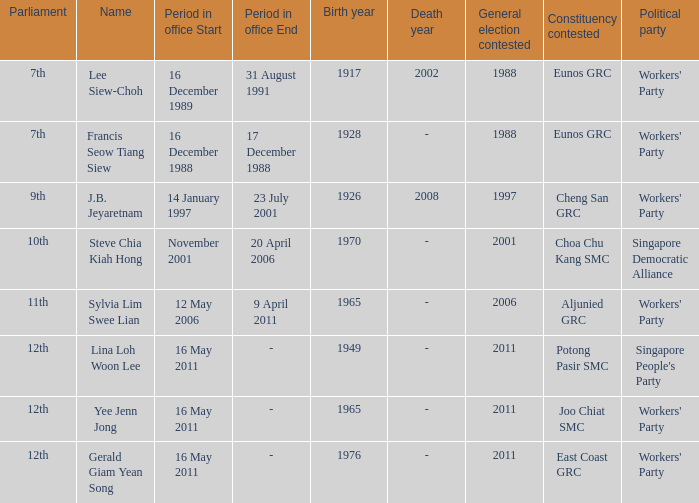During what period were parliament 11th? 12 May2006– 9 April 2011. 